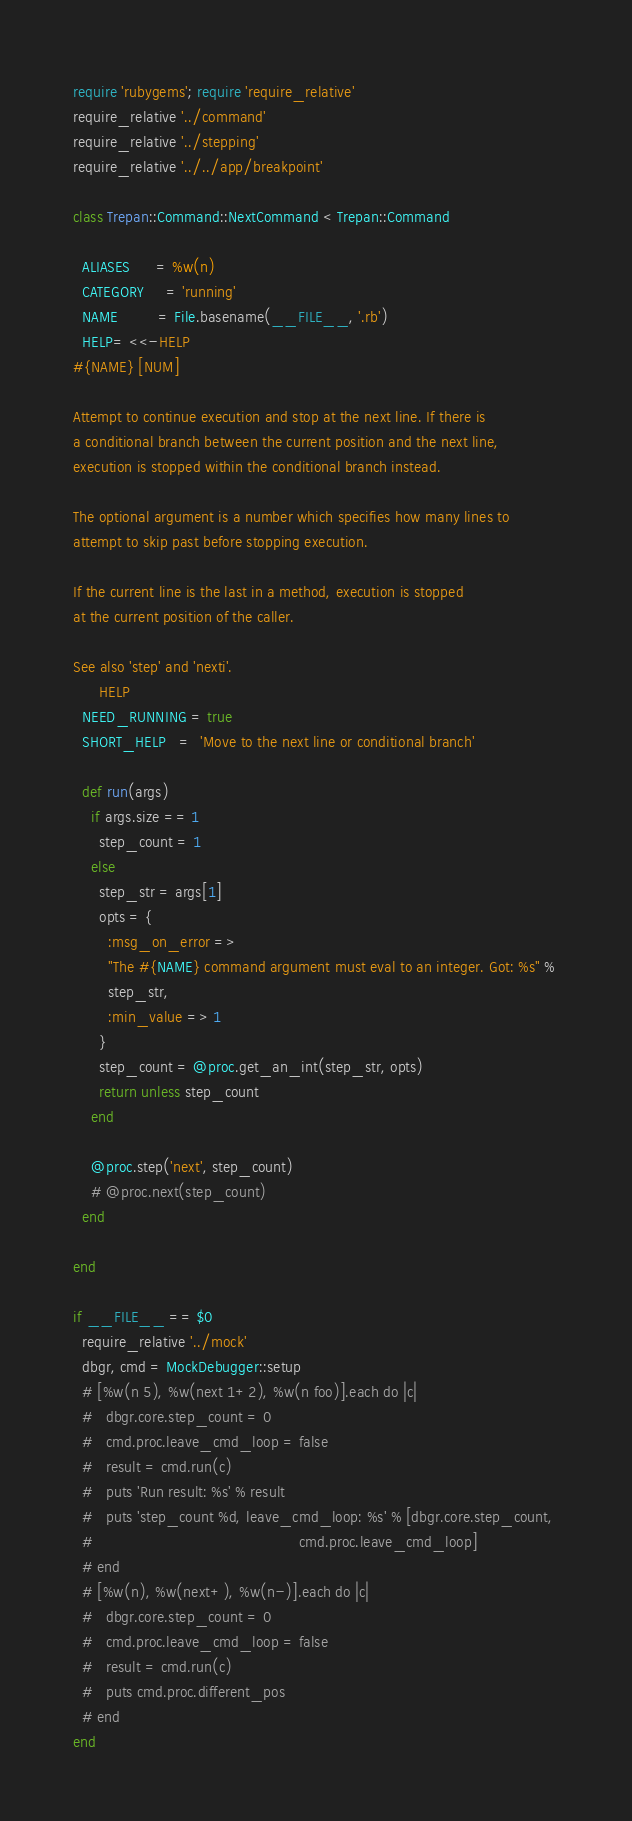<code> <loc_0><loc_0><loc_500><loc_500><_Ruby_>require 'rubygems'; require 'require_relative'
require_relative '../command'
require_relative '../stepping'
require_relative '../../app/breakpoint'

class Trepan::Command::NextCommand < Trepan::Command

  ALIASES      = %w(n)
  CATEGORY     = 'running'
  NAME         = File.basename(__FILE__, '.rb')
  HELP= <<-HELP
#{NAME} [NUM]

Attempt to continue execution and stop at the next line. If there is
a conditional branch between the current position and the next line,
execution is stopped within the conditional branch instead.

The optional argument is a number which specifies how many lines to
attempt to skip past before stopping execution.

If the current line is the last in a method, execution is stopped
at the current position of the caller.

See also 'step' and 'nexti'.
      HELP
  NEED_RUNNING = true
  SHORT_HELP   =  'Move to the next line or conditional branch'

  def run(args)
    if args.size == 1
      step_count = 1
    else
      step_str = args[1]
      opts = {
        :msg_on_error => 
        "The #{NAME} command argument must eval to an integer. Got: %s" % 
        step_str,
        :min_value => 1
      }
      step_count = @proc.get_an_int(step_str, opts)
      return unless step_count
    end

    @proc.step('next', step_count)
    # @proc.next(step_count)
  end
  
end

if __FILE__ == $0
  require_relative '../mock'
  dbgr, cmd = MockDebugger::setup
  # [%w(n 5), %w(next 1+2), %w(n foo)].each do |c|
  #   dbgr.core.step_count = 0
  #   cmd.proc.leave_cmd_loop = false
  #   result = cmd.run(c)
  #   puts 'Run result: %s' % result
  #   puts 'step_count %d, leave_cmd_loop: %s' % [dbgr.core.step_count,
  #                                               cmd.proc.leave_cmd_loop]
  # end
  # [%w(n), %w(next+), %w(n-)].each do |c|
  #   dbgr.core.step_count = 0
  #   cmd.proc.leave_cmd_loop = false
  #   result = cmd.run(c)
  #   puts cmd.proc.different_pos
  # end
end
</code> 